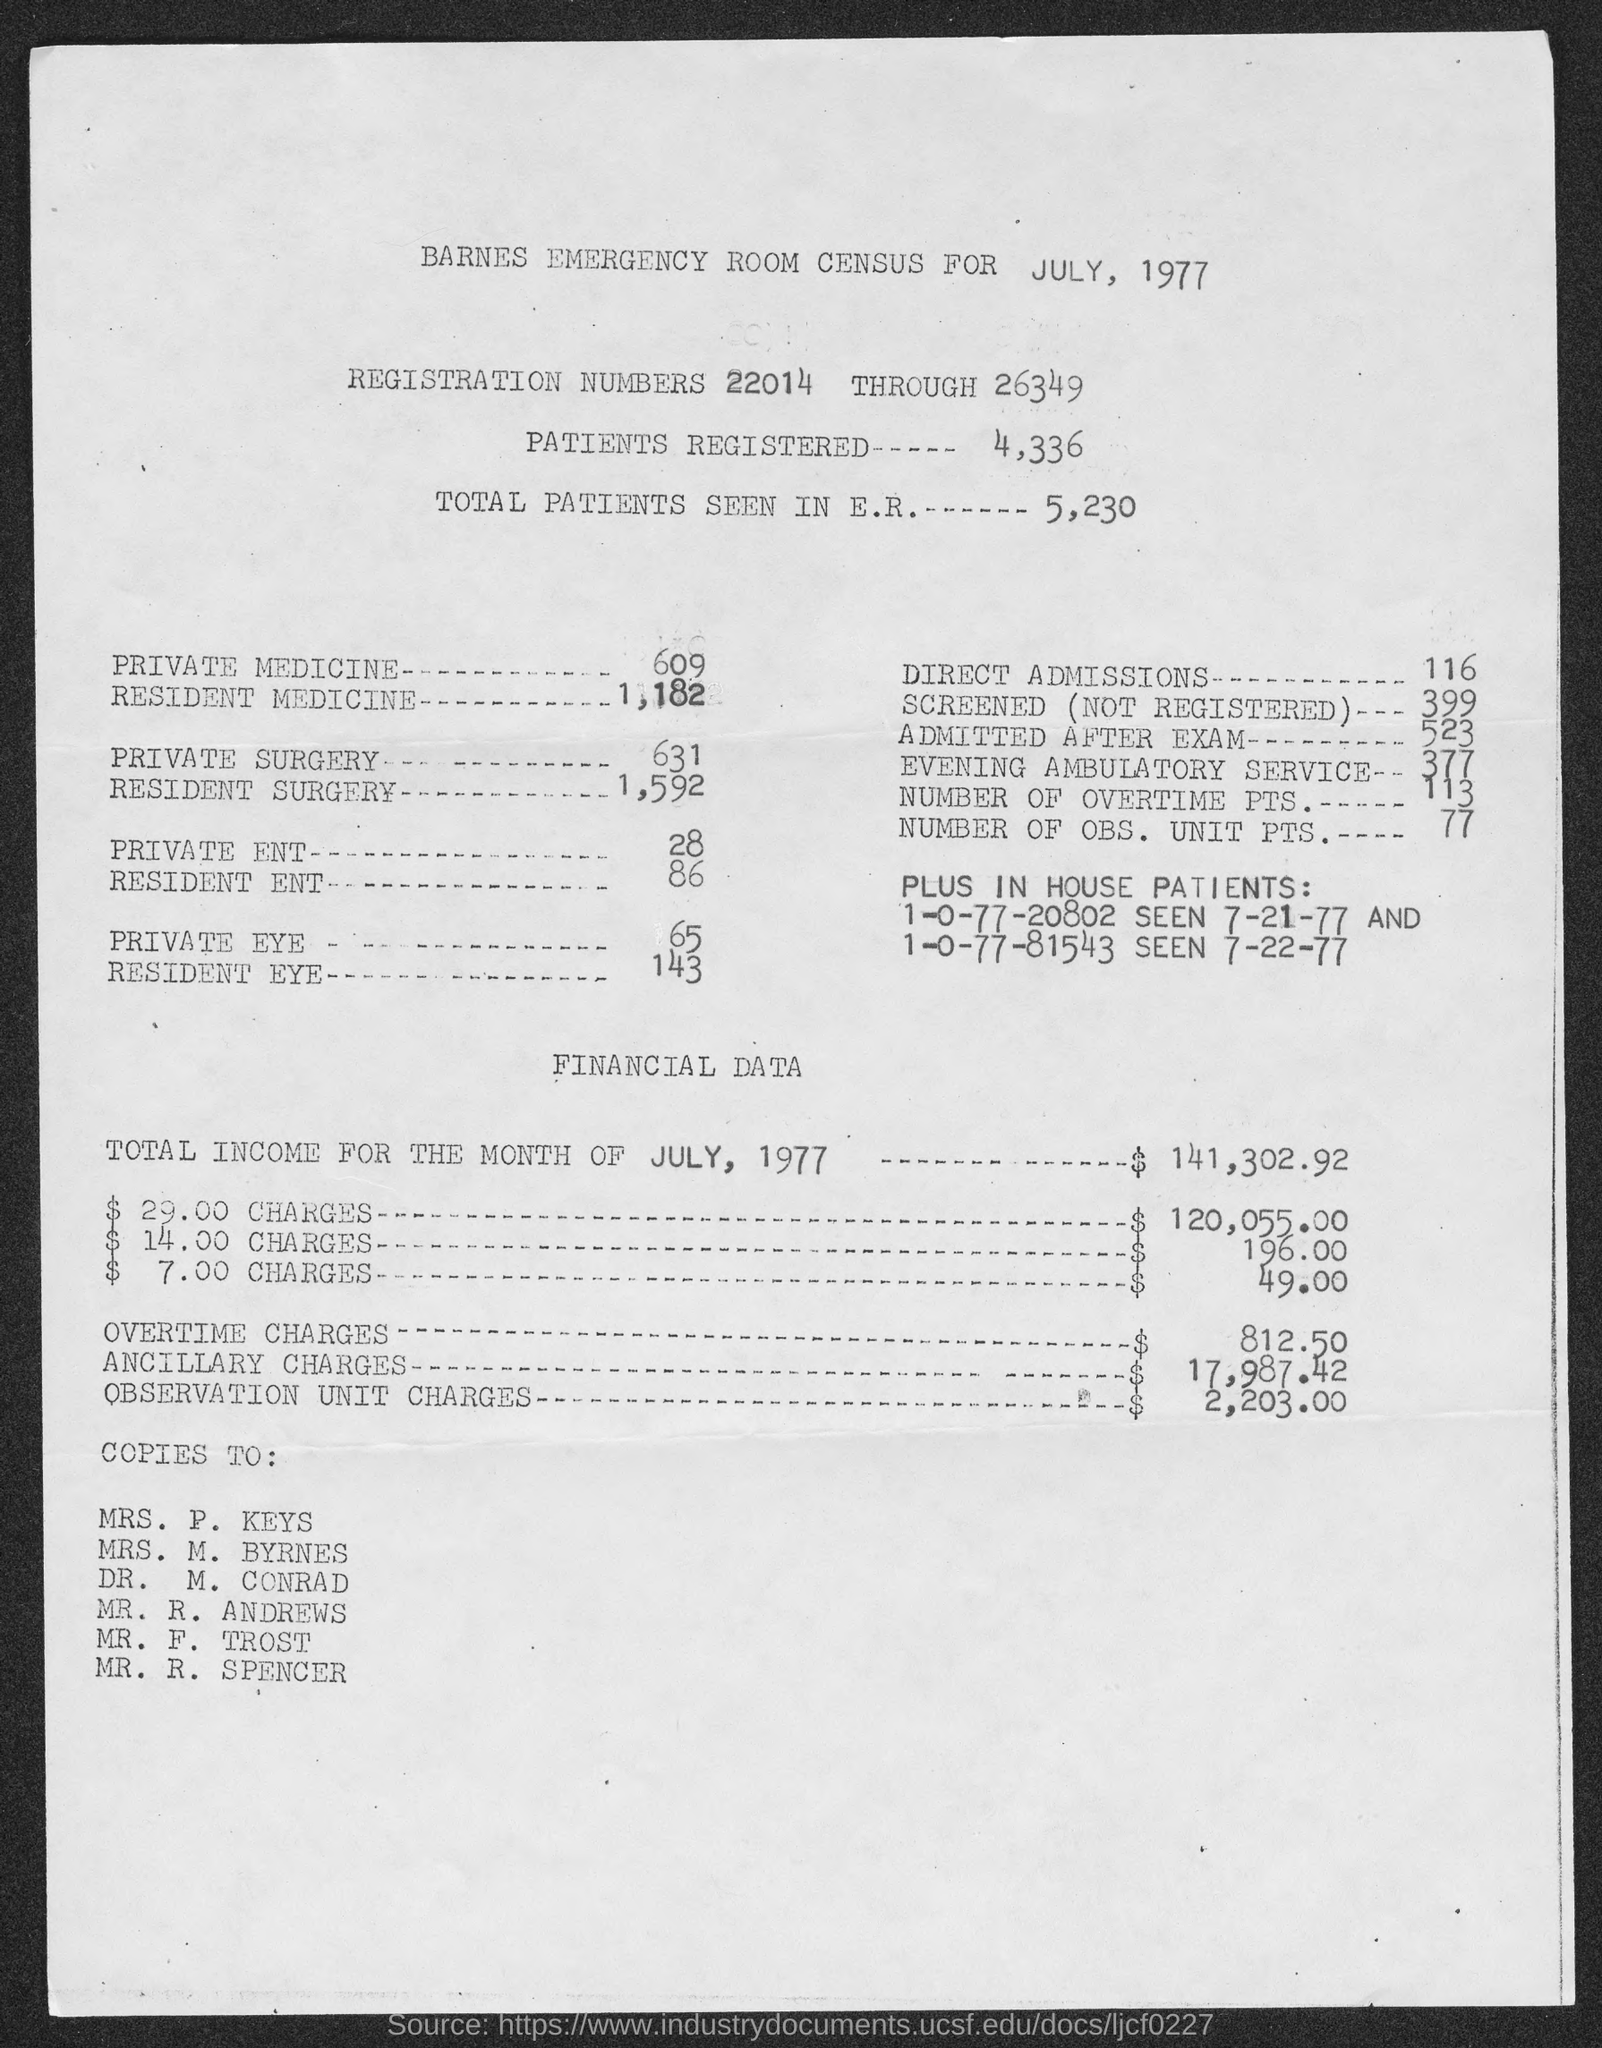List a handful of essential elements in this visual. There were 4,336 patients registered. After the exam, a total of 523 students were admitted. The total number of patients seen in the emergency room is 5,230. The total number of overtime points is 113. The overtime charges are $812.50. 